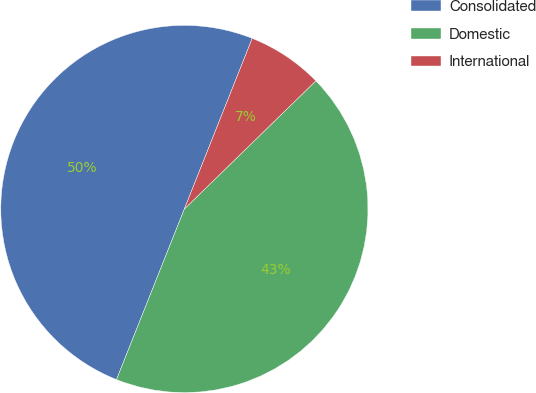<chart> <loc_0><loc_0><loc_500><loc_500><pie_chart><fcel>Consolidated<fcel>Domestic<fcel>International<nl><fcel>50.0%<fcel>43.32%<fcel>6.68%<nl></chart> 